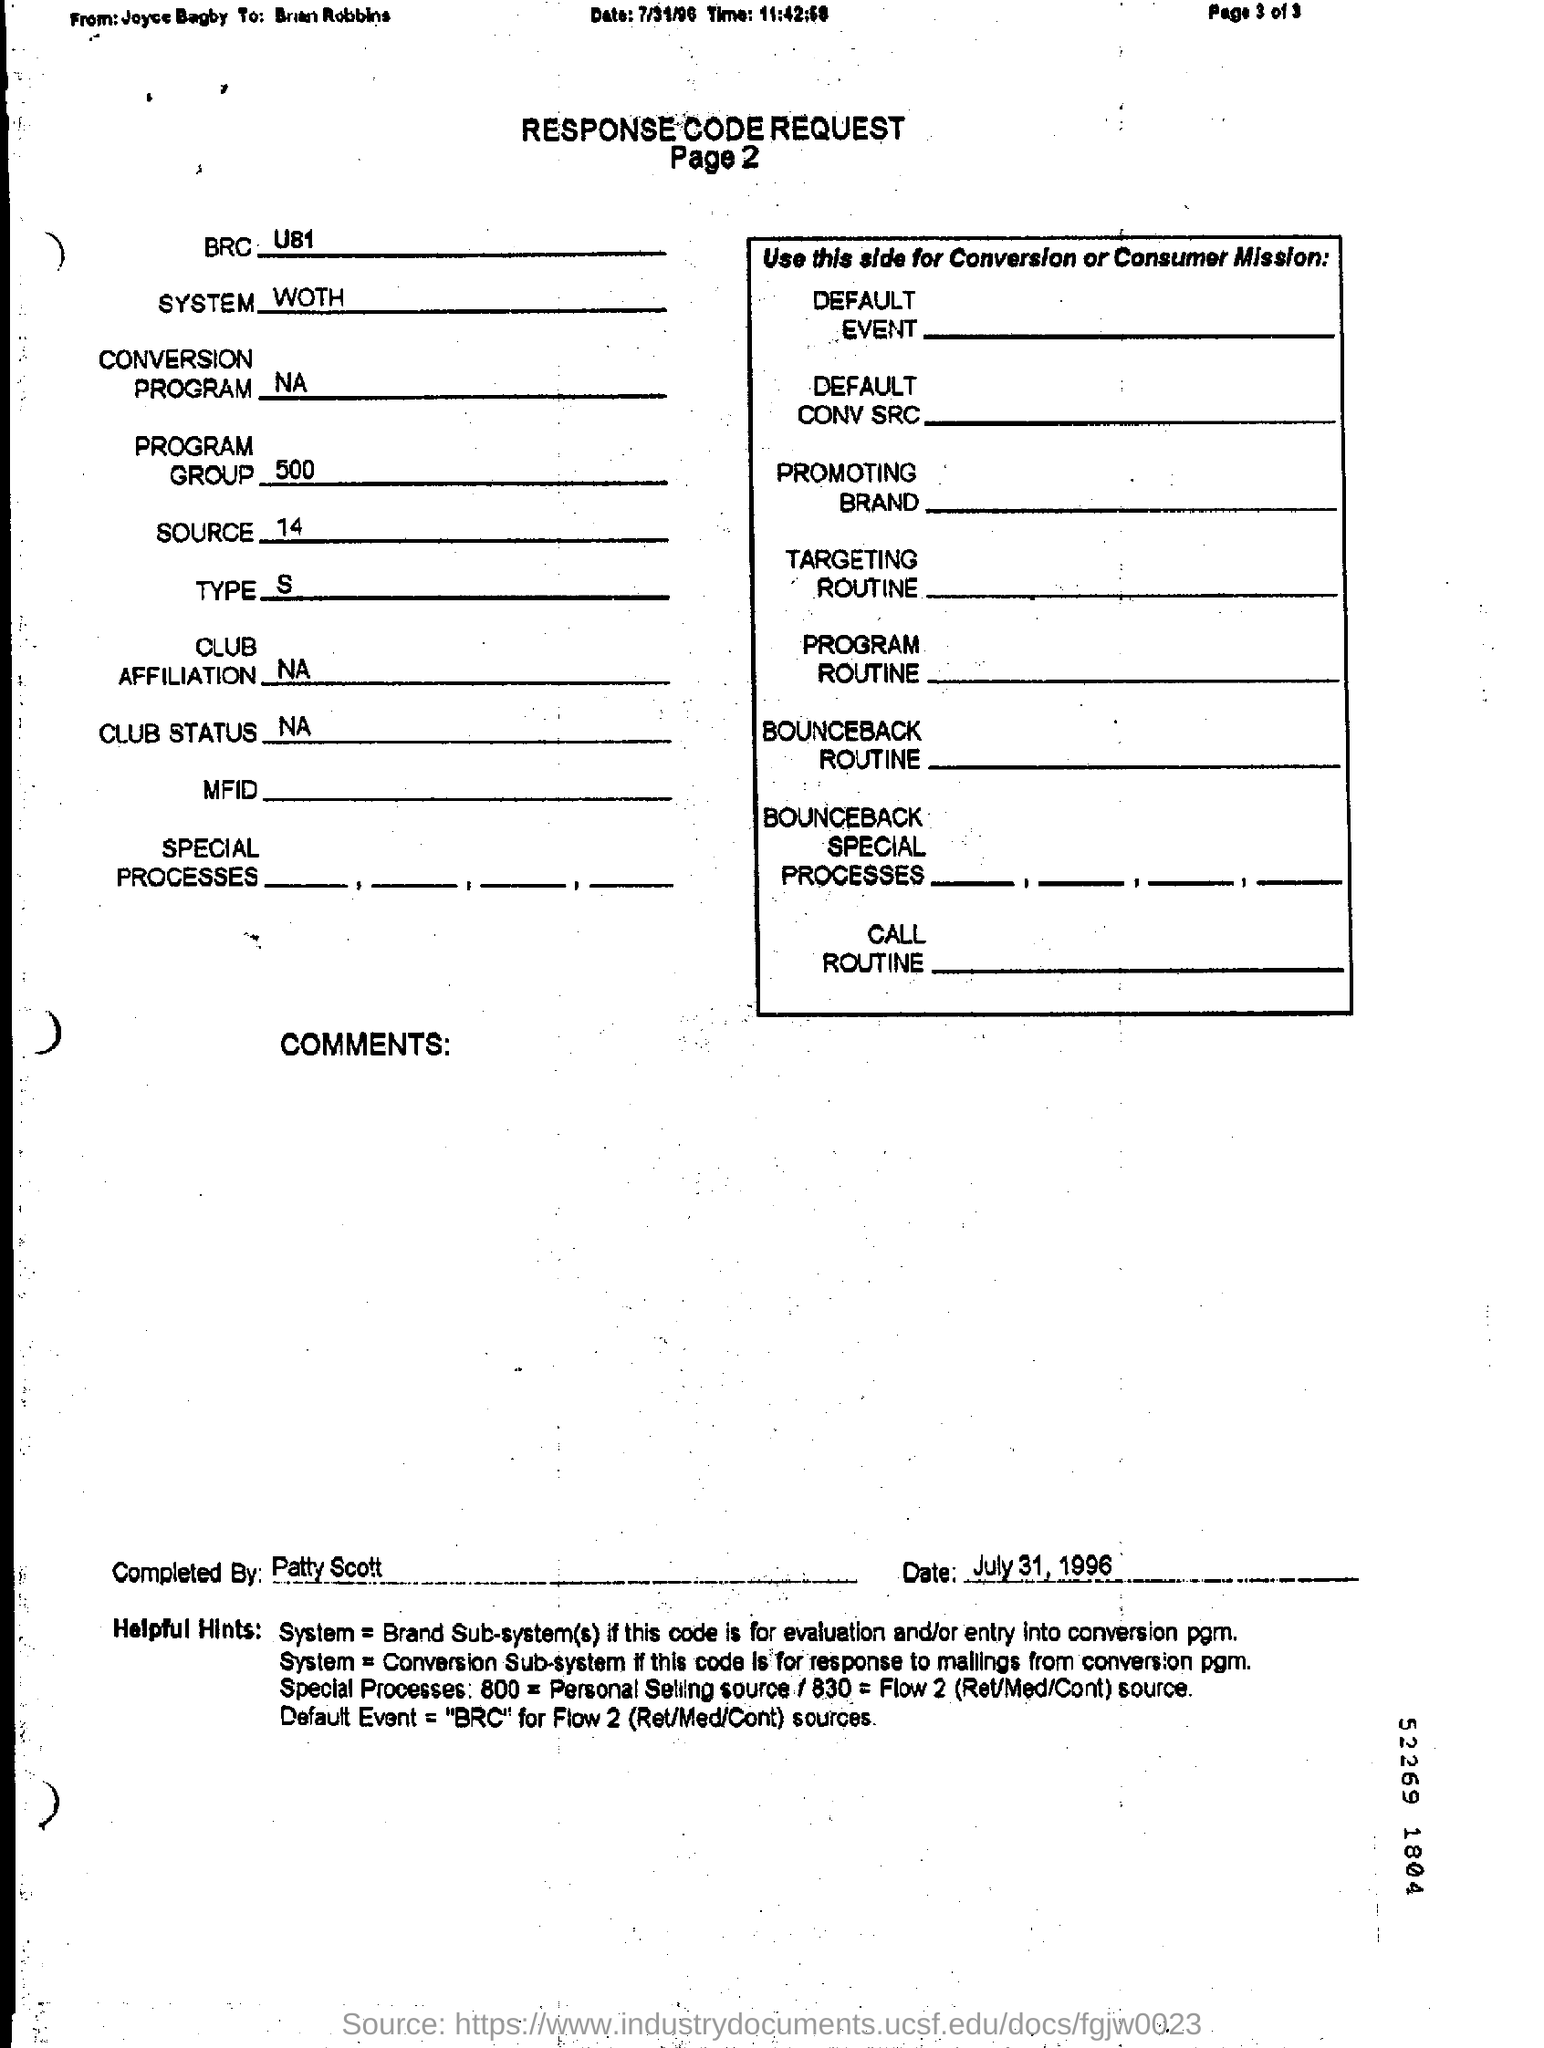What is the title of the document?
Keep it short and to the point. Response code request. What is the BRC?
Offer a terse response. U81. What is the system?
Make the answer very short. WOTH. What is the program group?
Provide a succinct answer. 500. What is the source?
Provide a succinct answer. 14. What is the type?
Give a very brief answer. S. This was completed by whom?
Your response must be concise. Patty Scott. What is the date?
Provide a succinct answer. July 31, 1996. 